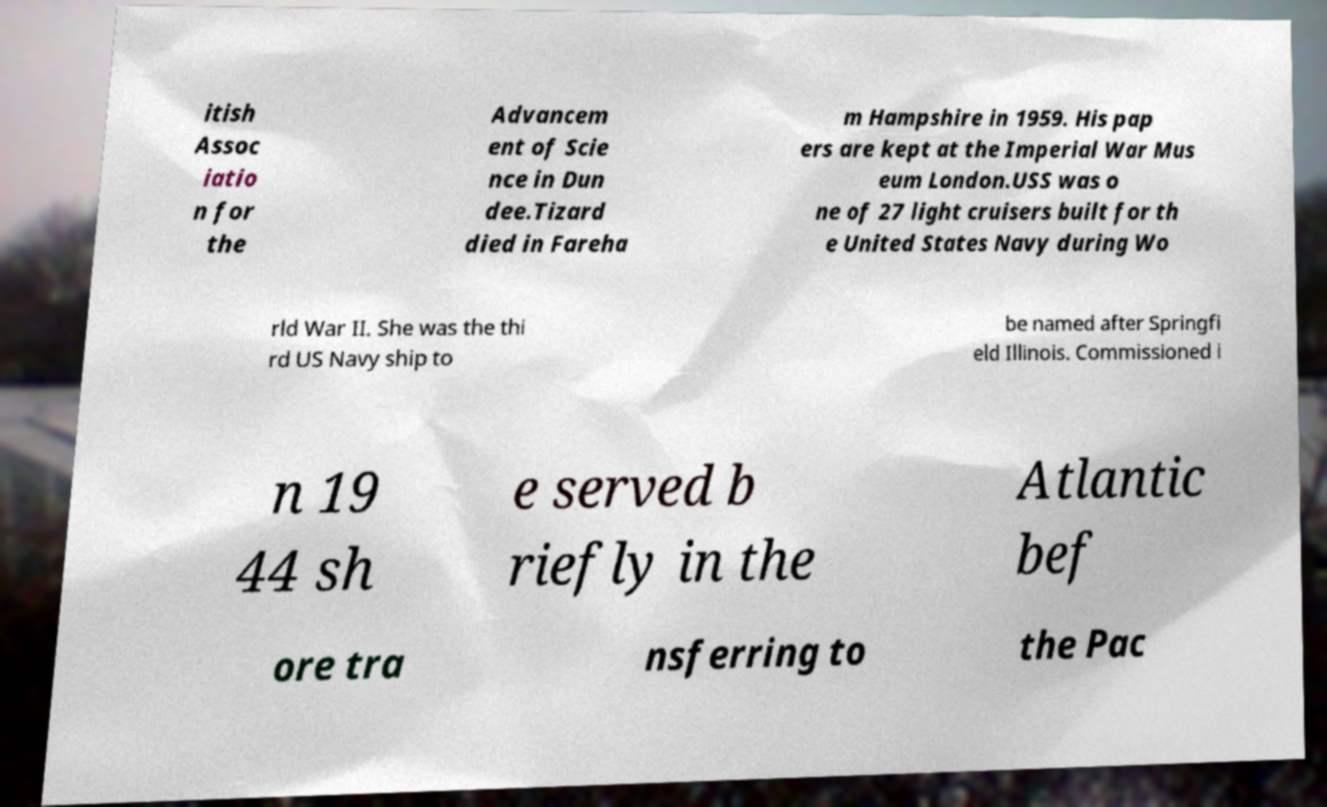For documentation purposes, I need the text within this image transcribed. Could you provide that? itish Assoc iatio n for the Advancem ent of Scie nce in Dun dee.Tizard died in Fareha m Hampshire in 1959. His pap ers are kept at the Imperial War Mus eum London.USS was o ne of 27 light cruisers built for th e United States Navy during Wo rld War II. She was the thi rd US Navy ship to be named after Springfi eld Illinois. Commissioned i n 19 44 sh e served b riefly in the Atlantic bef ore tra nsferring to the Pac 